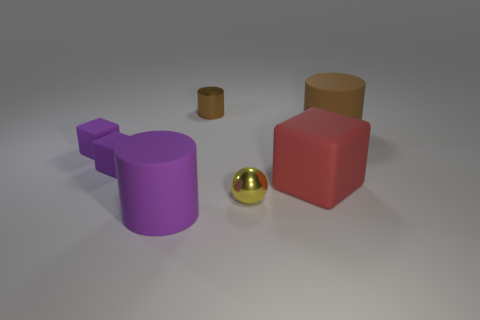What is the size of the brown cylinder in front of the tiny brown cylinder?
Your answer should be compact. Large. Is there a purple rubber thing that has the same size as the red rubber thing?
Provide a short and direct response. Yes. Do the block that is right of the purple matte cylinder and the brown shiny cylinder have the same size?
Offer a very short reply. No. The ball has what size?
Provide a short and direct response. Small. What color is the matte cylinder behind the large cylinder that is left of the tiny metal thing in front of the big red thing?
Your answer should be very brief. Brown. There is a cylinder that is right of the brown metallic cylinder; is its color the same as the small shiny cylinder?
Offer a terse response. Yes. How many small objects are behind the metal sphere and right of the large purple matte cylinder?
Your answer should be very brief. 1. What size is the other rubber thing that is the same shape as the large purple object?
Offer a terse response. Large. What number of small objects are on the left side of the cube right of the purple thing that is in front of the red block?
Offer a terse response. 4. What is the color of the large cylinder right of the purple cylinder in front of the ball?
Ensure brevity in your answer.  Brown. 